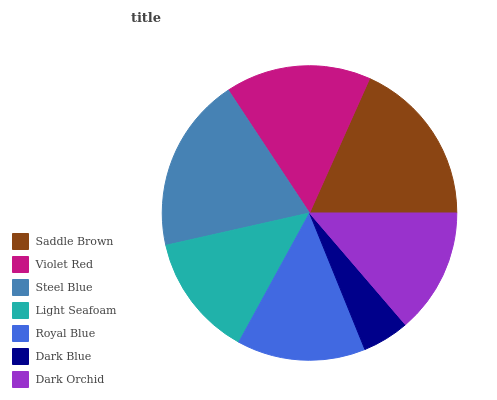Is Dark Blue the minimum?
Answer yes or no. Yes. Is Steel Blue the maximum?
Answer yes or no. Yes. Is Violet Red the minimum?
Answer yes or no. No. Is Violet Red the maximum?
Answer yes or no. No. Is Saddle Brown greater than Violet Red?
Answer yes or no. Yes. Is Violet Red less than Saddle Brown?
Answer yes or no. Yes. Is Violet Red greater than Saddle Brown?
Answer yes or no. No. Is Saddle Brown less than Violet Red?
Answer yes or no. No. Is Royal Blue the high median?
Answer yes or no. Yes. Is Royal Blue the low median?
Answer yes or no. Yes. Is Dark Blue the high median?
Answer yes or no. No. Is Violet Red the low median?
Answer yes or no. No. 